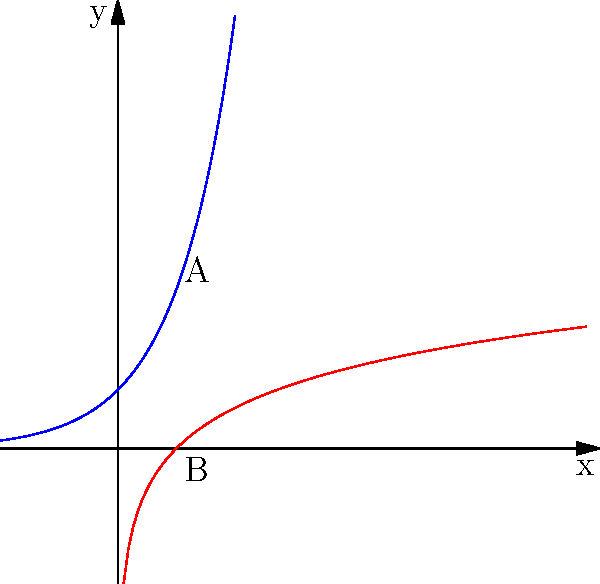In a distributed computing environment, you need to efficiently map and analyze data points from a hyperbolic space. Given the representation above, where the blue curve represents the hyperbolic space and the red curve represents its Euclidean projection, which data structure would be most suitable for storing and querying these non-Euclidean geometries while maintaining their spatial relationships? To efficiently map and analyze non-Euclidean geometries in a distributed computing environment, we need to consider the following steps:

1. Understand the nature of hyperbolic space:
   - Hyperbolic space has negative curvature, which is represented by the blue curve in the diagram.
   - The Euclidean projection (red curve) doesn't preserve all spatial relationships.

2. Consider the requirements for data storage and querying:
   - Preserve distance and angular relationships between points
   - Support efficient nearest neighbor searches
   - Allow for scalable distributed processing

3. Evaluate potential data structures:
   - Traditional R-trees or B-trees are not ideal as they are designed for Euclidean space
   - Specialized structures for non-Euclidean spaces are needed

4. Identify the most suitable structure:
   - Hyperbolic trees or H-trees are specifically designed for hyperbolic space
   - They preserve the hierarchical structure and spatial relationships of hyperbolic geometry
   - Can be easily distributed across multiple nodes in a cluster

5. Consider implementation in a distributed environment:
   - H-trees can be partitioned and distributed across nodes
   - Each node can handle a subset of the hyperbolic space
   - Allows for parallel processing and efficient querying

Therefore, the most suitable data structure for this scenario would be a Hyperbolic tree (H-tree), as it preserves the spatial relationships of hyperbolic space while allowing for efficient distributed processing and querying.
Answer: Hyperbolic tree (H-tree) 